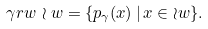<formula> <loc_0><loc_0><loc_500><loc_500>\gamma r w \, \wr w = \{ p _ { \gamma } ( x ) \, | \, x \in \wr w \} .</formula> 